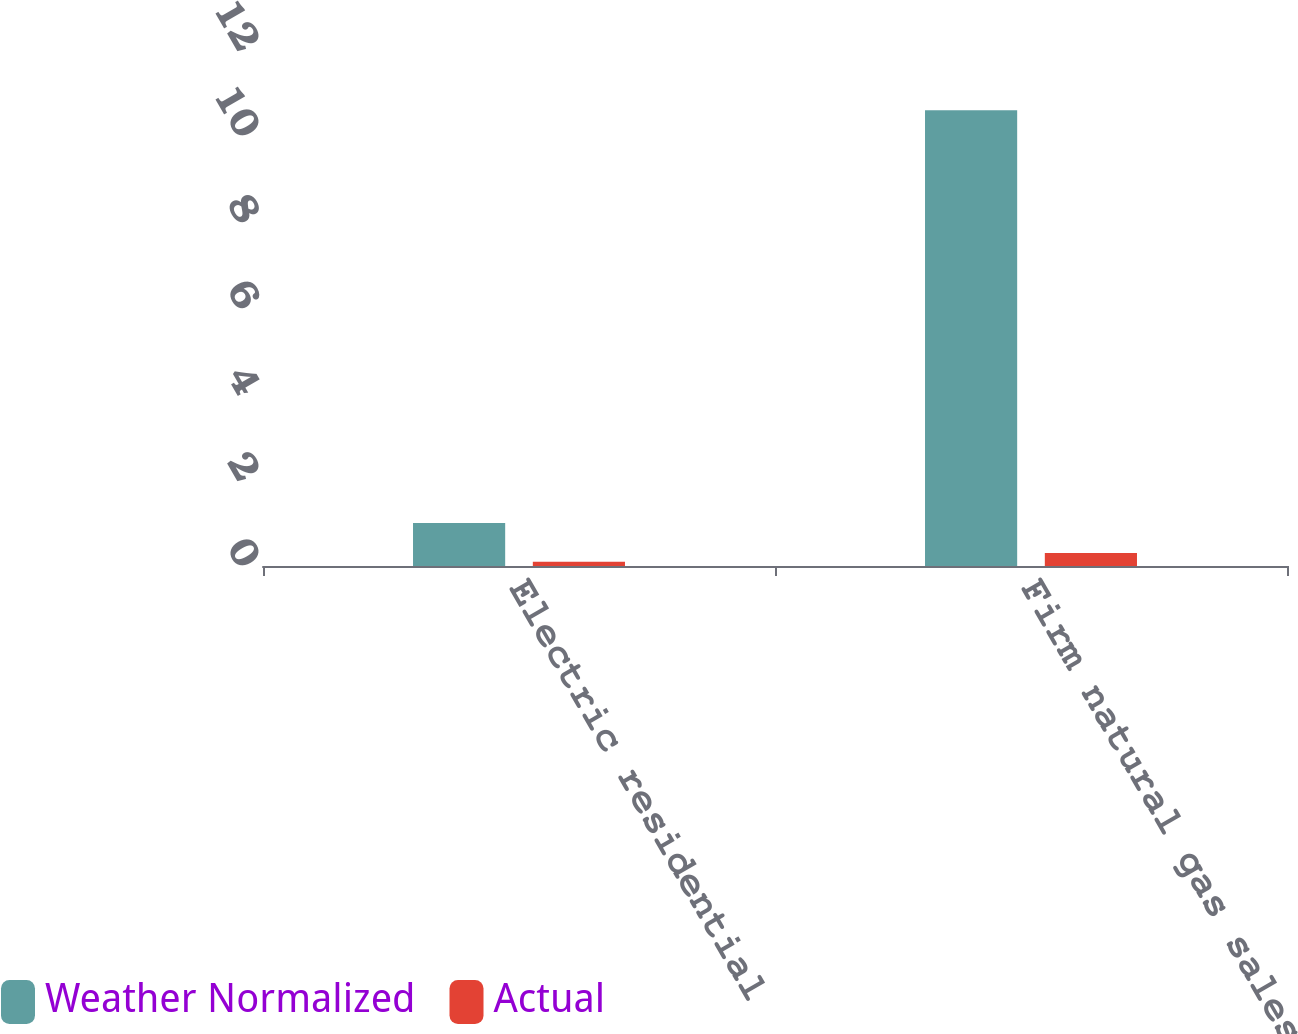<chart> <loc_0><loc_0><loc_500><loc_500><stacked_bar_chart><ecel><fcel>Electric residential<fcel>Firm natural gas sales (a)<nl><fcel>Weather Normalized<fcel>1<fcel>10.6<nl><fcel>Actual<fcel>0.1<fcel>0.3<nl></chart> 